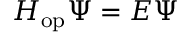Convert formula to latex. <formula><loc_0><loc_0><loc_500><loc_500>H _ { o p } \Psi = E \Psi</formula> 